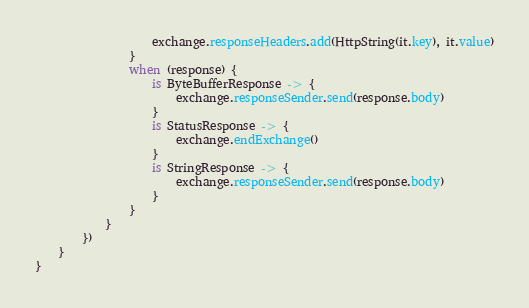Convert code to text. <code><loc_0><loc_0><loc_500><loc_500><_Kotlin_>                    exchange.responseHeaders.add(HttpString(it.key), it.value)
                }
                when (response) {
                    is ByteBufferResponse -> {
                        exchange.responseSender.send(response.body)
                    }
                    is StatusResponse -> {
                        exchange.endExchange()
                    }
                    is StringResponse -> {
                        exchange.responseSender.send(response.body)
                    }
                }
            }
        })
    }
}
</code> 